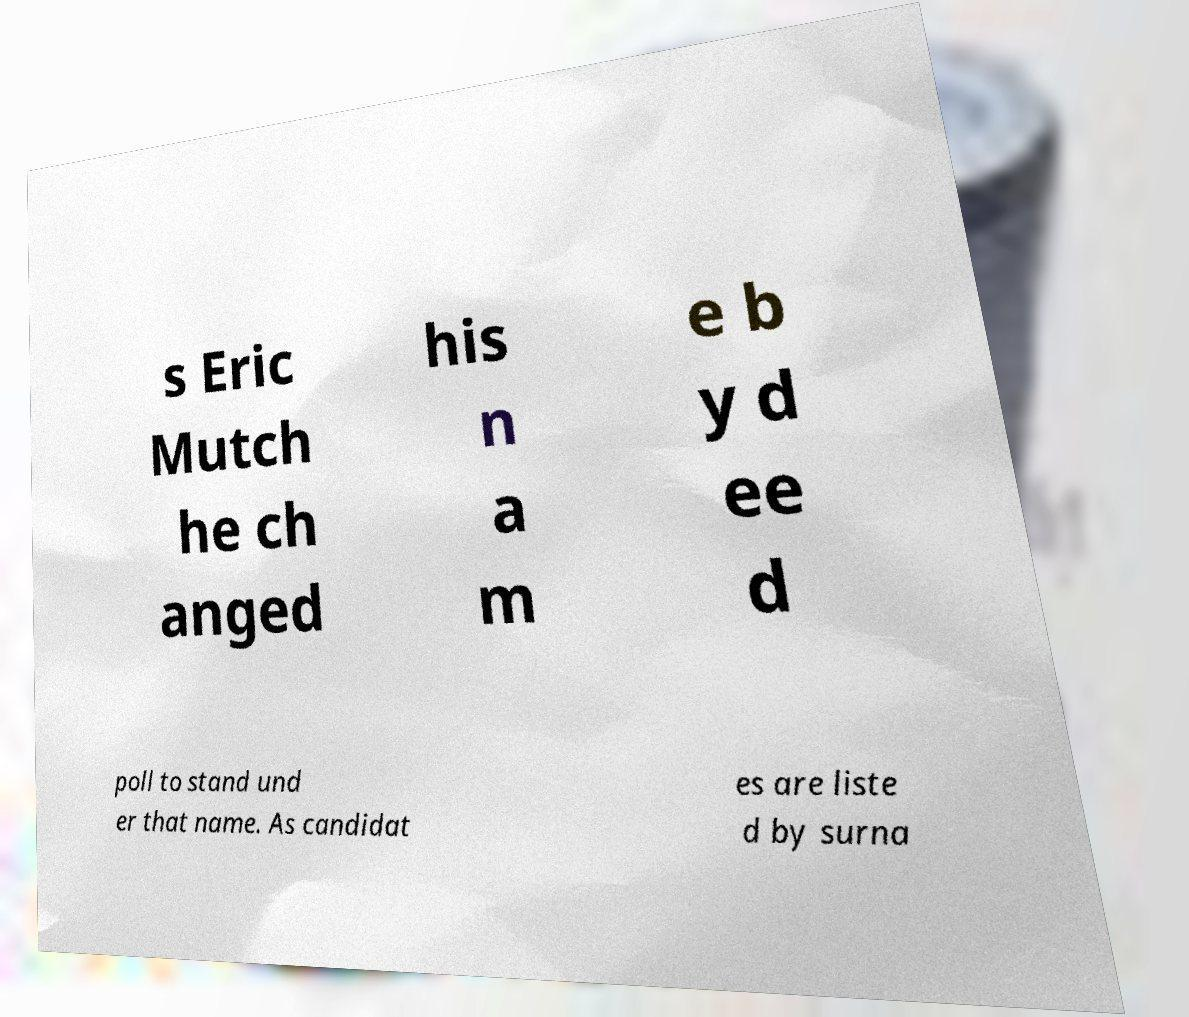There's text embedded in this image that I need extracted. Can you transcribe it verbatim? s Eric Mutch he ch anged his n a m e b y d ee d poll to stand und er that name. As candidat es are liste d by surna 